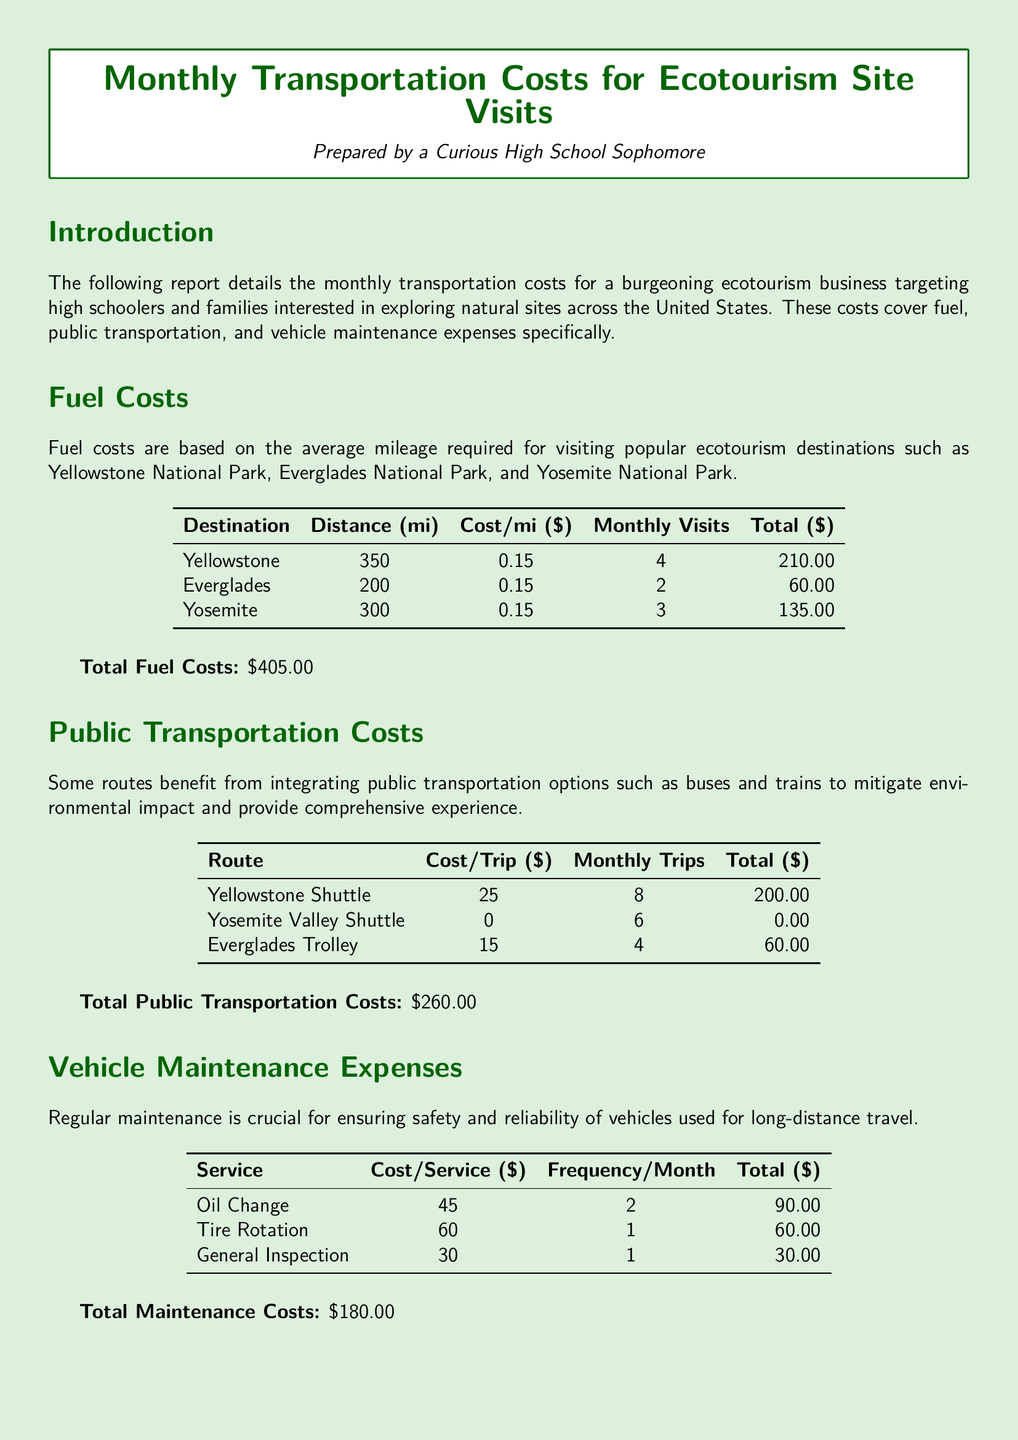What is the total fuel cost? The total fuel cost is presented in the document under the Fuel Costs section.
Answer: $405.00 How many monthly visits are planned for Yellowstone? The number of monthly visits for Yellowstone is specified in the Fuel Costs table.
Answer: 4 What is the cost of a ride on the Yosemite Valley Shuttle? The cost of a ride on the Yosemite Valley Shuttle is mentioned in the Public Transportation Costs table.
Answer: 0 How often is an oil change performed? The frequency of oil changes is found in the Vehicle Maintenance Expenses table.
Answer: 2 What is the sum of total public transportation costs and total maintenance costs? To find the sum, add total public transportation costs ($260.00) and total maintenance costs ($180.00).
Answer: $440.00 What is the total monthly transportation cost? The total monthly transportation cost is the final amount presented in the Conclusion section of the report.
Answer: $845.00 What service costs $60 and is performed once a month? The specific service that is $60 and scheduled once a month is listed in the Vehicle Maintenance Expenses table.
Answer: Tire Rotation What transportation option covers 6 monthly trips without cost? The document provides information on a transportation option with no cost and the number of trips in the Public Transportation Costs table.
Answer: Yosemite Valley Shuttle How many monthly trips are taken using the Everglades Trolley? The number of monthly trips for the Everglades Trolley is detailed in the Public Transportation Costs table.
Answer: 4 